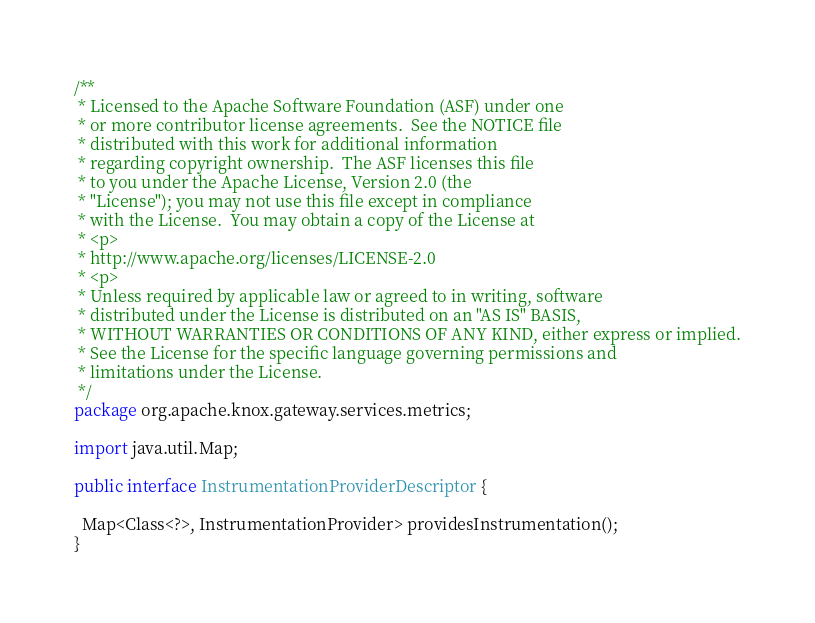Convert code to text. <code><loc_0><loc_0><loc_500><loc_500><_Java_>/**
 * Licensed to the Apache Software Foundation (ASF) under one
 * or more contributor license agreements.  See the NOTICE file
 * distributed with this work for additional information
 * regarding copyright ownership.  The ASF licenses this file
 * to you under the Apache License, Version 2.0 (the
 * "License"); you may not use this file except in compliance
 * with the License.  You may obtain a copy of the License at
 * <p>
 * http://www.apache.org/licenses/LICENSE-2.0
 * <p>
 * Unless required by applicable law or agreed to in writing, software
 * distributed under the License is distributed on an "AS IS" BASIS,
 * WITHOUT WARRANTIES OR CONDITIONS OF ANY KIND, either express or implied.
 * See the License for the specific language governing permissions and
 * limitations under the License.
 */
package org.apache.knox.gateway.services.metrics;

import java.util.Map;

public interface InstrumentationProviderDescriptor {

  Map<Class<?>, InstrumentationProvider> providesInstrumentation();
}
</code> 